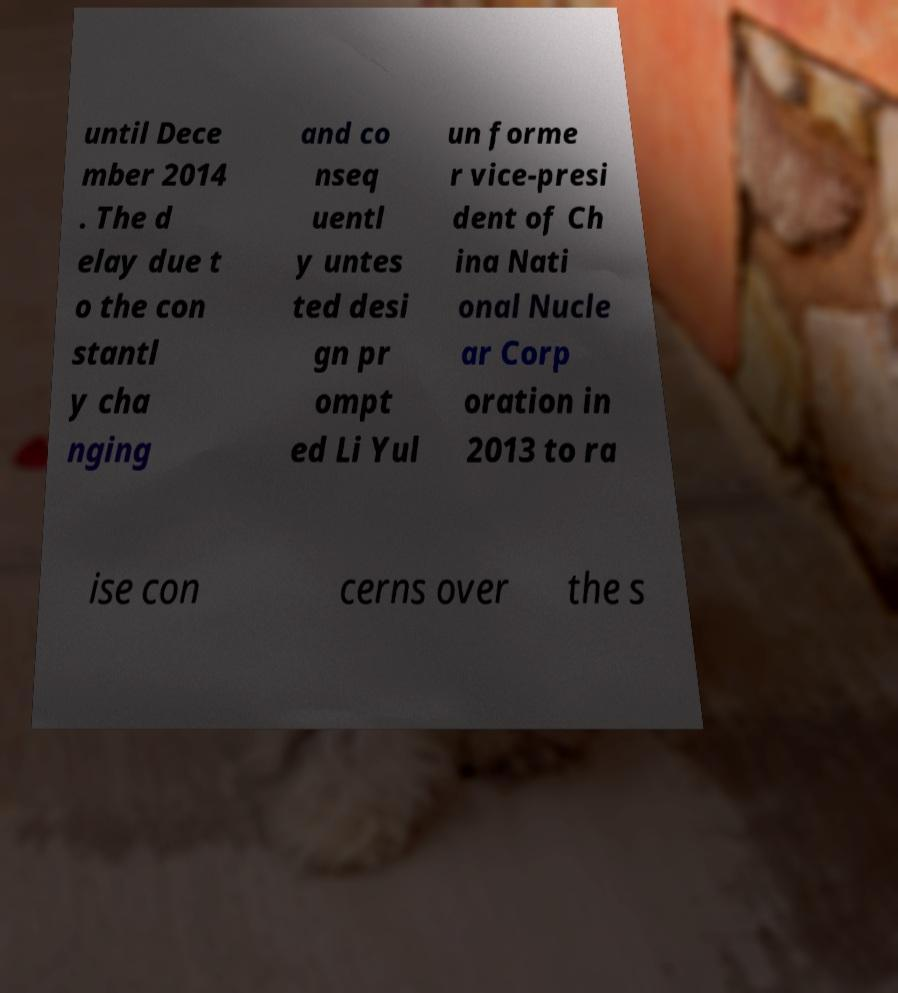Can you accurately transcribe the text from the provided image for me? until Dece mber 2014 . The d elay due t o the con stantl y cha nging and co nseq uentl y untes ted desi gn pr ompt ed Li Yul un forme r vice-presi dent of Ch ina Nati onal Nucle ar Corp oration in 2013 to ra ise con cerns over the s 